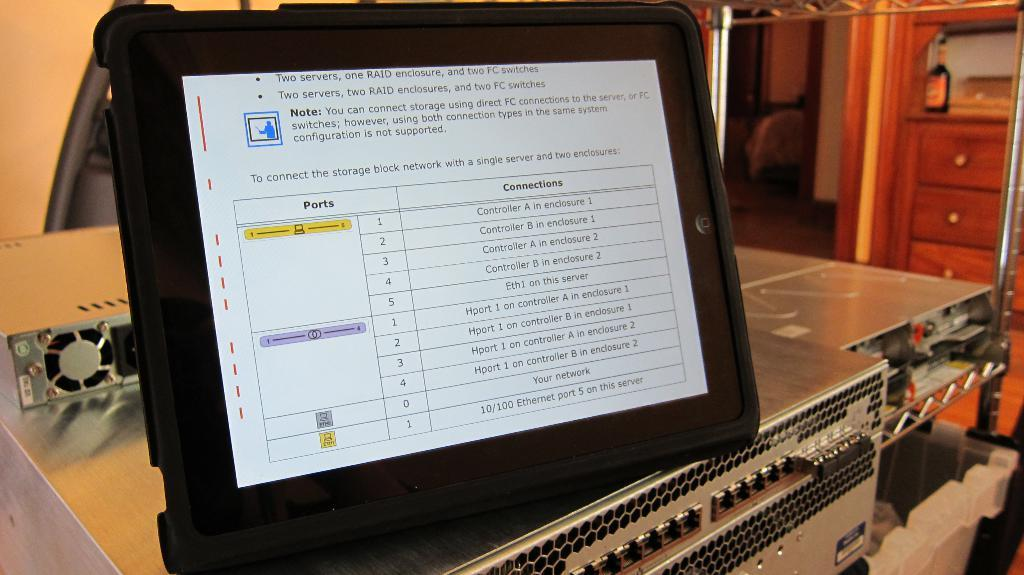What is the main object in the image? There is a tab in the image. Can you describe another object in the image? There is a bottle in the image. What hobbies are the people in the image engaged in? There are no people present in the image, so their hobbies cannot be determined. Can you describe the kiss between the two individuals in the image? There are no individuals or kisses present in the image. 